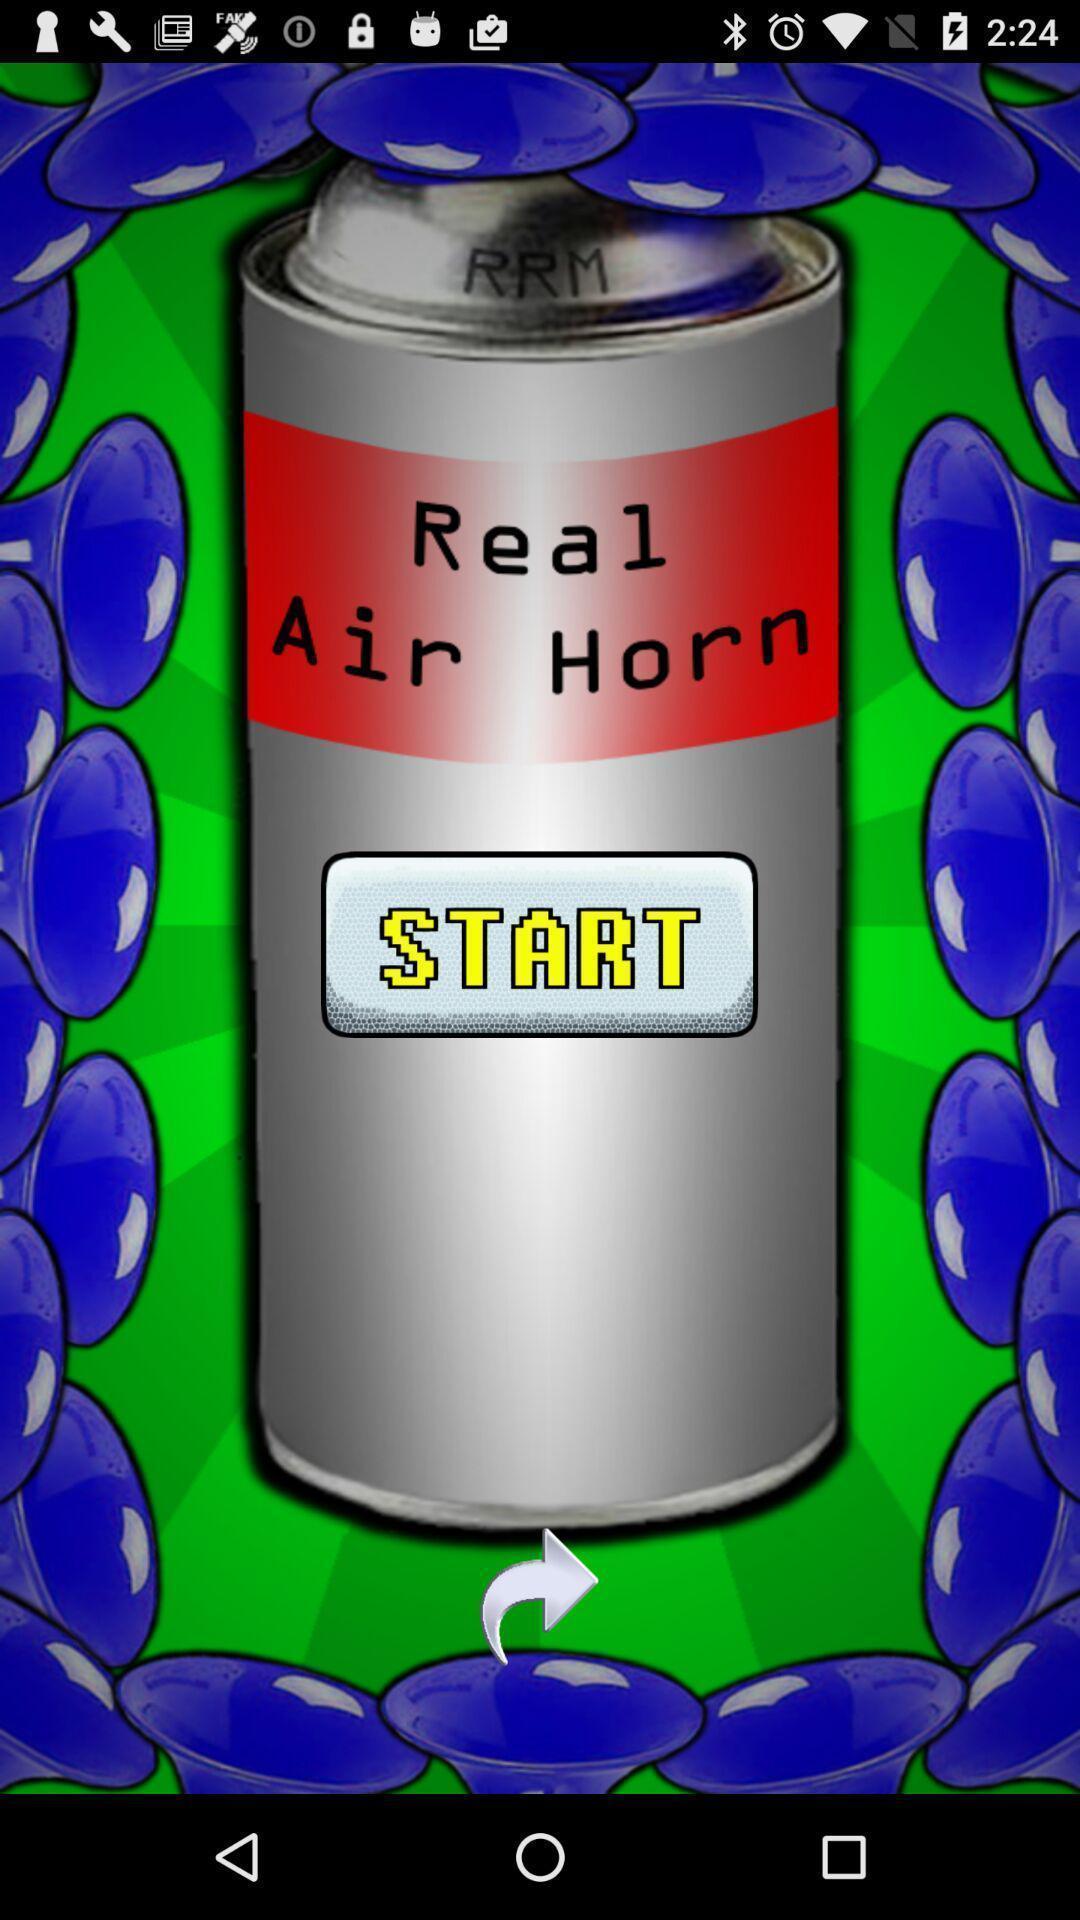Explain the elements present in this screenshot. Welcome page displayed to start. 